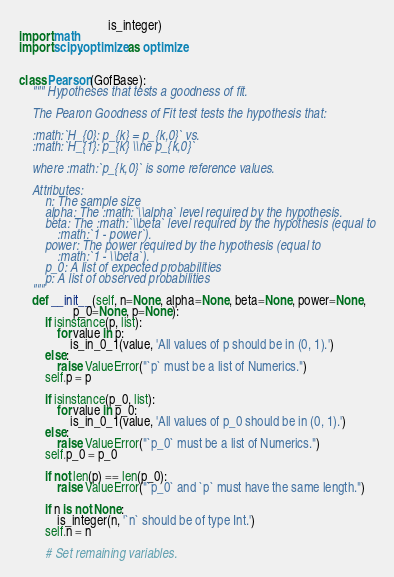<code> <loc_0><loc_0><loc_500><loc_500><_Python_>                            is_integer)
import math
import scipy.optimize as optimize


class Pearson(GofBase):
    """ Hypotheses that tests a goodness of fit.

    The Pearon Goodness of Fit test tests the hypothesis that:

    :math:`H_{0}: p_{k} = p_{k,0}` vs.
    :math:`H_{1}: p_{k} \\ne p_{k,0}`

    where :math:`p_{k,0}` is some reference values.

    Attributes:
        n: The sample size
        alpha: The :math:`\\alpha` level required by the hypothesis.
        beta: The :math:`\\beta` level required by the hypothesis (equal to
            :math:`1 - power`).
        power: The power required by the hypothesis (equal to
            :math:`1 - \\beta`).
        p_0: A list of expected probabilities
        p: A list of observed probabilities
    """
    def __init__(self, n=None, alpha=None, beta=None, power=None,
                 p_0=None, p=None):
        if isinstance(p, list):
            for value in p:
                is_in_0_1(value, 'All values of p should be in (0, 1).')
        else:
            raise ValueError("`p` must be a list of Numerics.")
        self.p = p

        if isinstance(p_0, list):
            for value in p_0:
                is_in_0_1(value, 'All values of p_0 should be in (0, 1).')
        else:
            raise ValueError("`p_0` must be a list of Numerics.")
        self.p_0 = p_0

        if not len(p) == len(p_0):
            raise ValueError("`p_0` and `p` must have the same length.")

        if n is not None:
            is_integer(n, '`n` should be of type Int.')
        self.n = n

        # Set remaining variables.</code> 